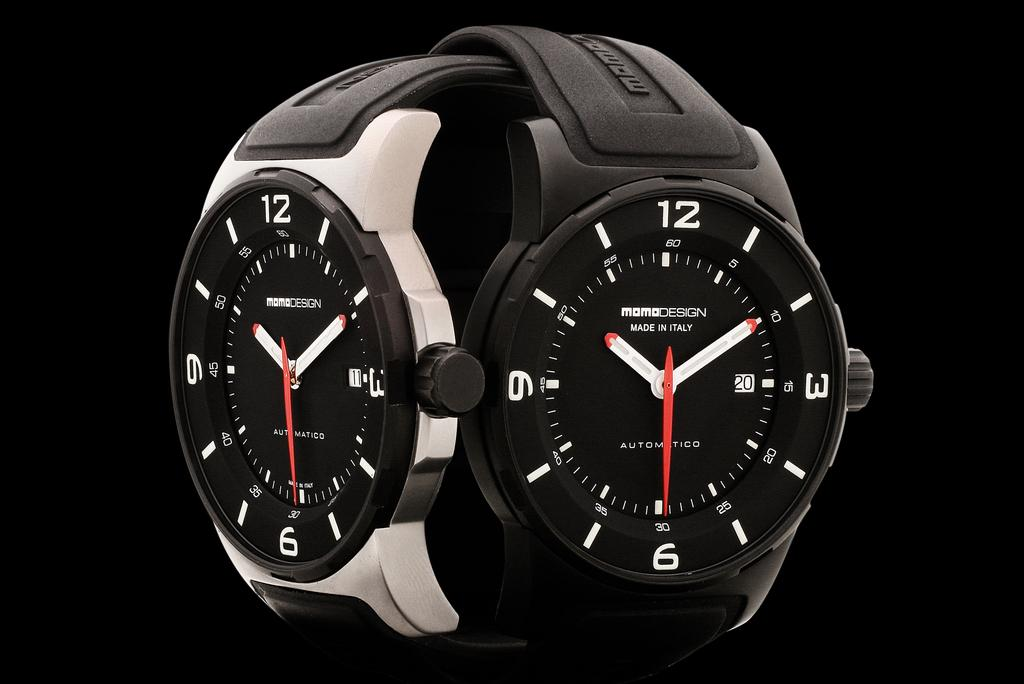<image>
Create a compact narrative representing the image presented. Two watches both display a time of 10:10:30. 